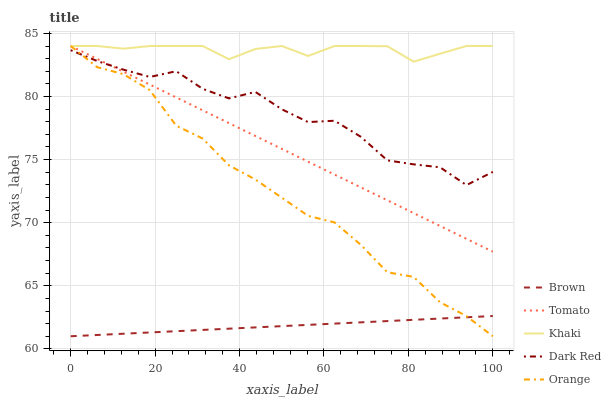Does Brown have the minimum area under the curve?
Answer yes or no. Yes. Does Khaki have the maximum area under the curve?
Answer yes or no. Yes. Does Orange have the minimum area under the curve?
Answer yes or no. No. Does Orange have the maximum area under the curve?
Answer yes or no. No. Is Brown the smoothest?
Answer yes or no. Yes. Is Dark Red the roughest?
Answer yes or no. Yes. Is Orange the smoothest?
Answer yes or no. No. Is Orange the roughest?
Answer yes or no. No. Does Brown have the lowest value?
Answer yes or no. Yes. Does Khaki have the lowest value?
Answer yes or no. No. Does Khaki have the highest value?
Answer yes or no. Yes. Does Brown have the highest value?
Answer yes or no. No. Is Brown less than Dark Red?
Answer yes or no. Yes. Is Khaki greater than Dark Red?
Answer yes or no. Yes. Does Dark Red intersect Tomato?
Answer yes or no. Yes. Is Dark Red less than Tomato?
Answer yes or no. No. Is Dark Red greater than Tomato?
Answer yes or no. No. Does Brown intersect Dark Red?
Answer yes or no. No. 